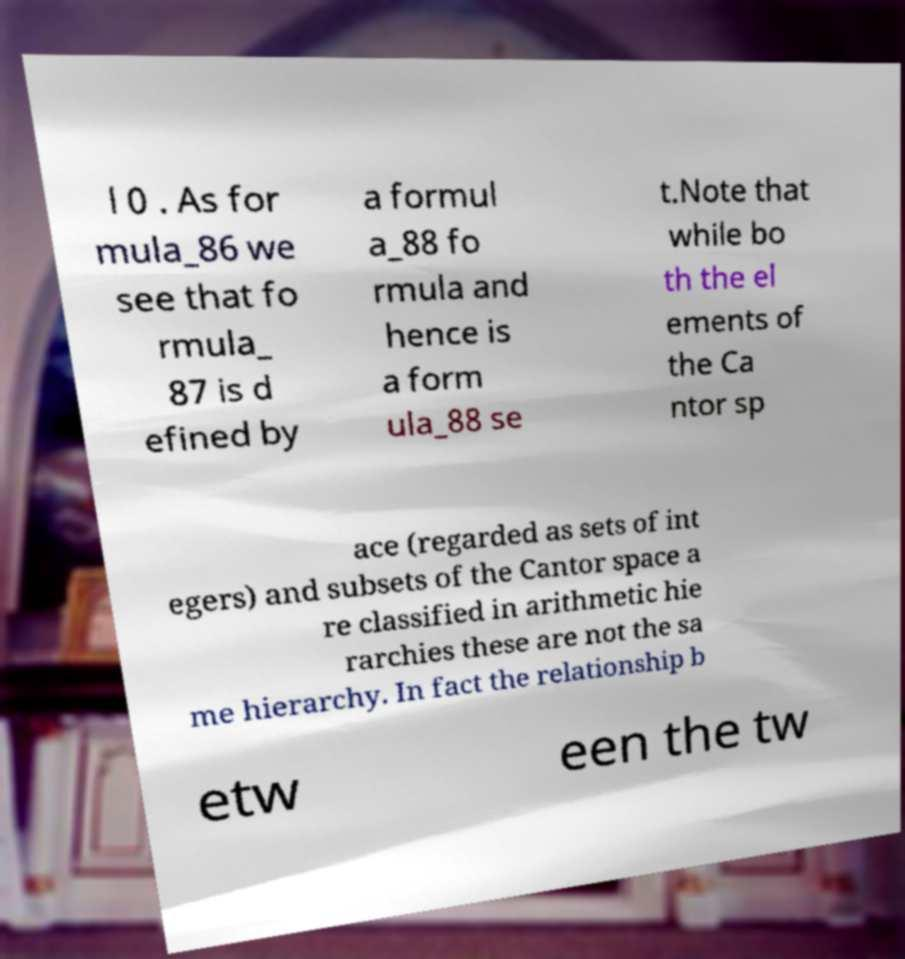Please read and relay the text visible in this image. What does it say? l 0 . As for mula_86 we see that fo rmula_ 87 is d efined by a formul a_88 fo rmula and hence is a form ula_88 se t.Note that while bo th the el ements of the Ca ntor sp ace (regarded as sets of int egers) and subsets of the Cantor space a re classified in arithmetic hie rarchies these are not the sa me hierarchy. In fact the relationship b etw een the tw 